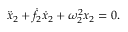<formula> <loc_0><loc_0><loc_500><loc_500>\begin{array} { r } { \ddot { x } _ { 2 } + \dot { f } _ { 2 } \dot { x } _ { 2 } + \omega _ { 2 } ^ { 2 } x _ { 2 } = 0 . } \end{array}</formula> 